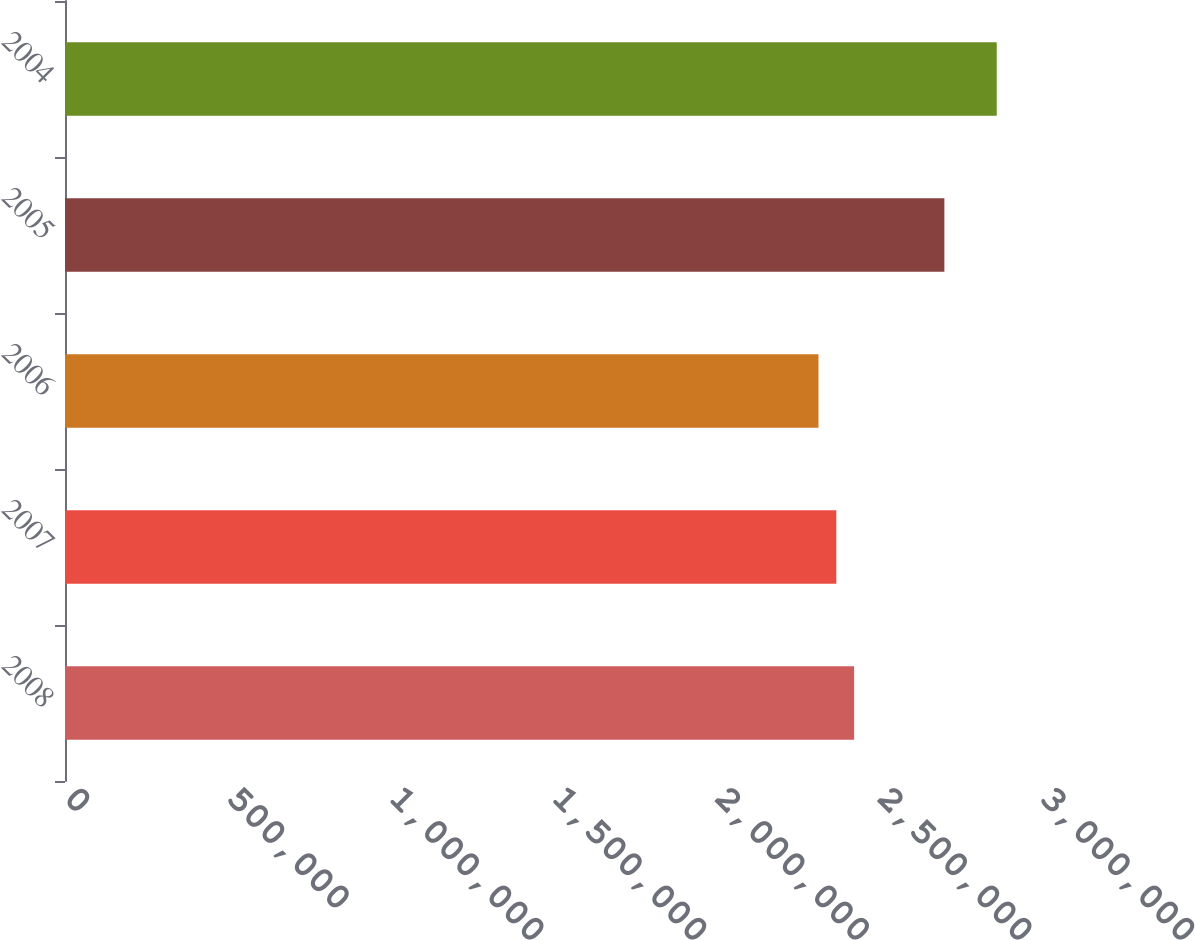Convert chart to OTSL. <chart><loc_0><loc_0><loc_500><loc_500><bar_chart><fcel>2008<fcel>2007<fcel>2006<fcel>2005<fcel>2004<nl><fcel>2.4256e+06<fcel>2.3708e+06<fcel>2.316e+06<fcel>2.703e+06<fcel>2.864e+06<nl></chart> 